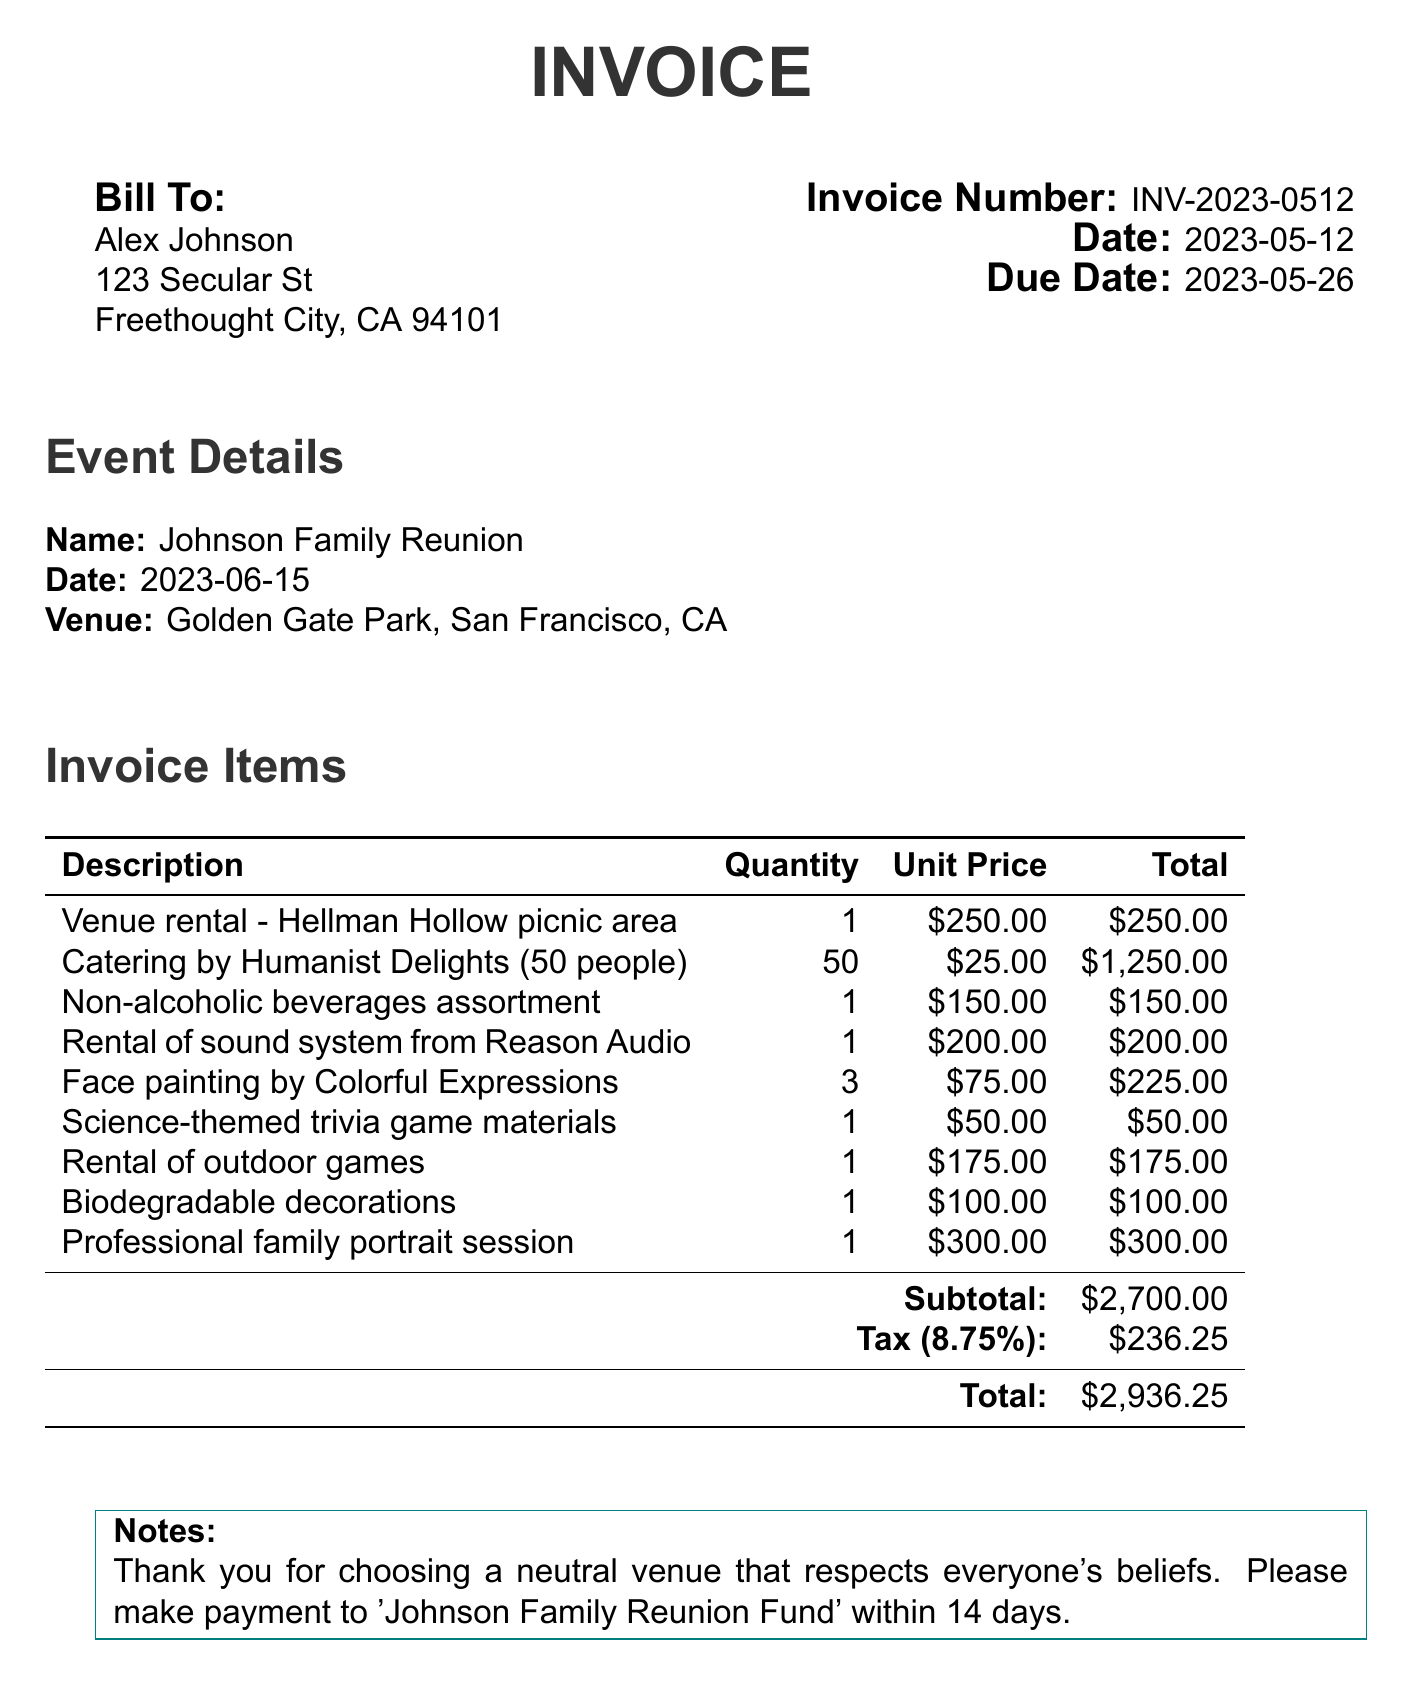What is the invoice number? The invoice number is clearly stated at the top of the document under "Invoice Number."
Answer: INV-2023-0512 What is the total amount due? The total amount due is found at the bottom of the invoice in the total section.
Answer: $2,936.25 What is the venue for the family reunion? The venue is mentioned in the event details section of the document.
Answer: Golden Gate Park, San Francisco, CA How many people are catered for? The number of people catered for is indicated in the catering line item.
Answer: 50 What is the tax rate applied to the subtotal? The tax rate is mentioned in the tax section of the invoice.
Answer: 8.75% What is the due date for the payment? The due date can be found next to the "Due Date" heading in the invoice details.
Answer: 2023-05-26 Which company provided the catering service? The catering service provider is listed in the catering line item on the invoice.
Answer: Humanist Delights What does the note at the bottom mention? The note section contains a message thanking the client and providing payment details.
Answer: Thank you for choosing a neutral venue that respects everyone's beliefs 